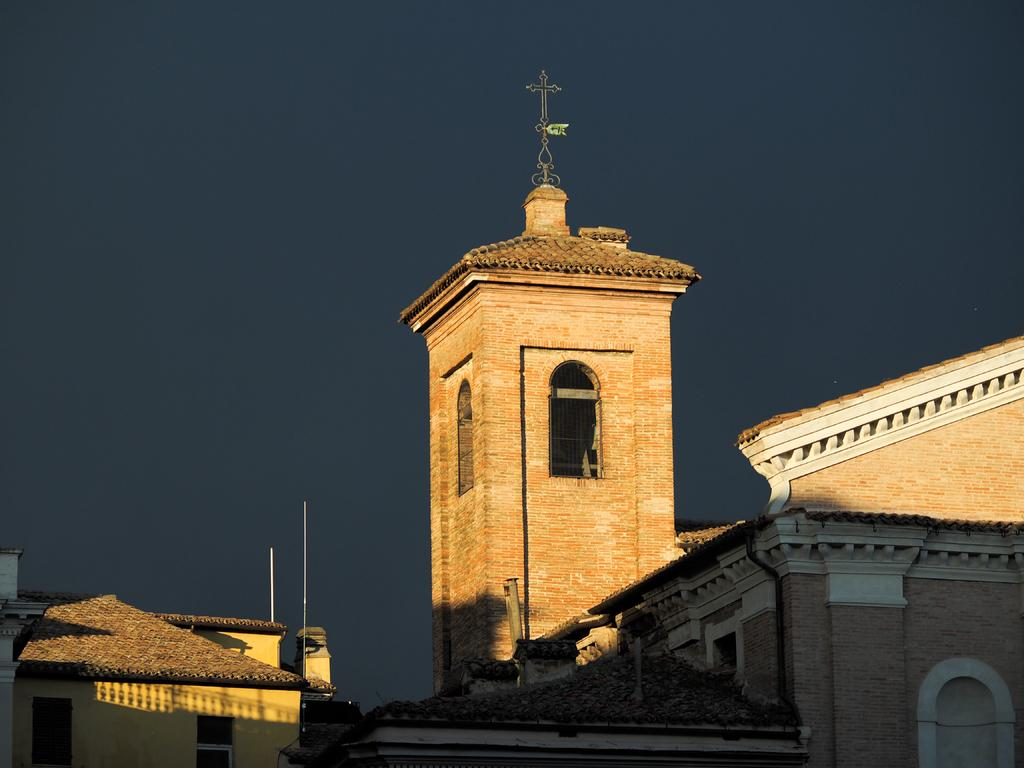What type of structures are present in the image? There are buildings in the image. What can be seen on the buildings? There are metal objects on the buildings. What is visible in the background of the image? The sky is visible in the background of the image. Can you describe the bear wearing a coat and hat in the image? There is no bear, coat, or hat present in the image. 